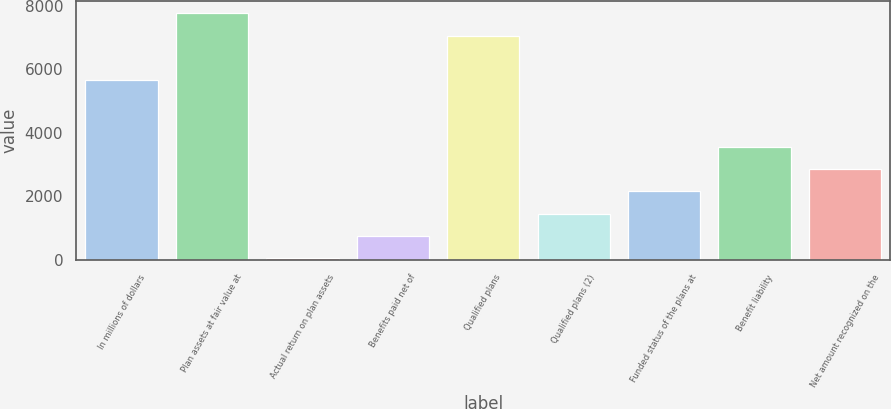Convert chart to OTSL. <chart><loc_0><loc_0><loc_500><loc_500><bar_chart><fcel>In millions of dollars<fcel>Plan assets at fair value at<fcel>Actual return on plan assets<fcel>Benefits paid net of<fcel>Qualified plans<fcel>Qualified plans (2)<fcel>Funded status of the plans at<fcel>Benefit liability<fcel>Net amount recognized on the<nl><fcel>5656.8<fcel>7757.1<fcel>56<fcel>756.1<fcel>7057<fcel>1456.2<fcel>2156.3<fcel>3556.5<fcel>2856.4<nl></chart> 